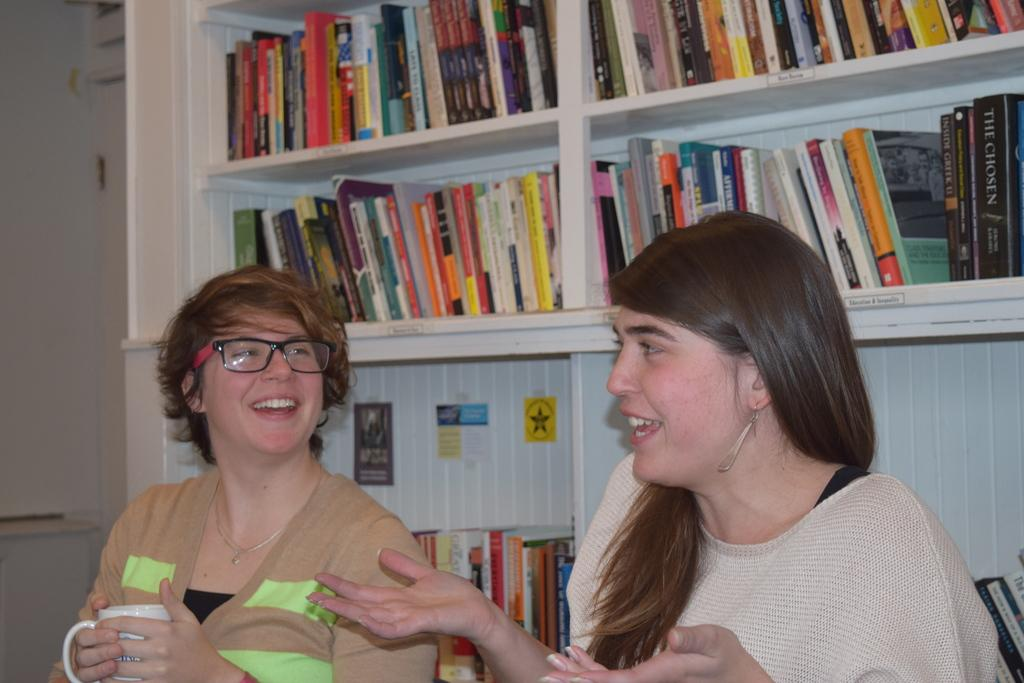How many people are present in the image? There are two persons in the image. What can be seen in the background of the image? There are books in shelves and a wall visible in the background of the image. Can you describe the setting where the image might have been taken? The image may have been taken in a room, given the presence of shelves and a wall in the background. What type of bomb can be seen in the image? There is no bomb present in the image. Can you describe the haircut of the persons in the image? The provided facts do not mention any details about the haircuts of the persons in the image. 